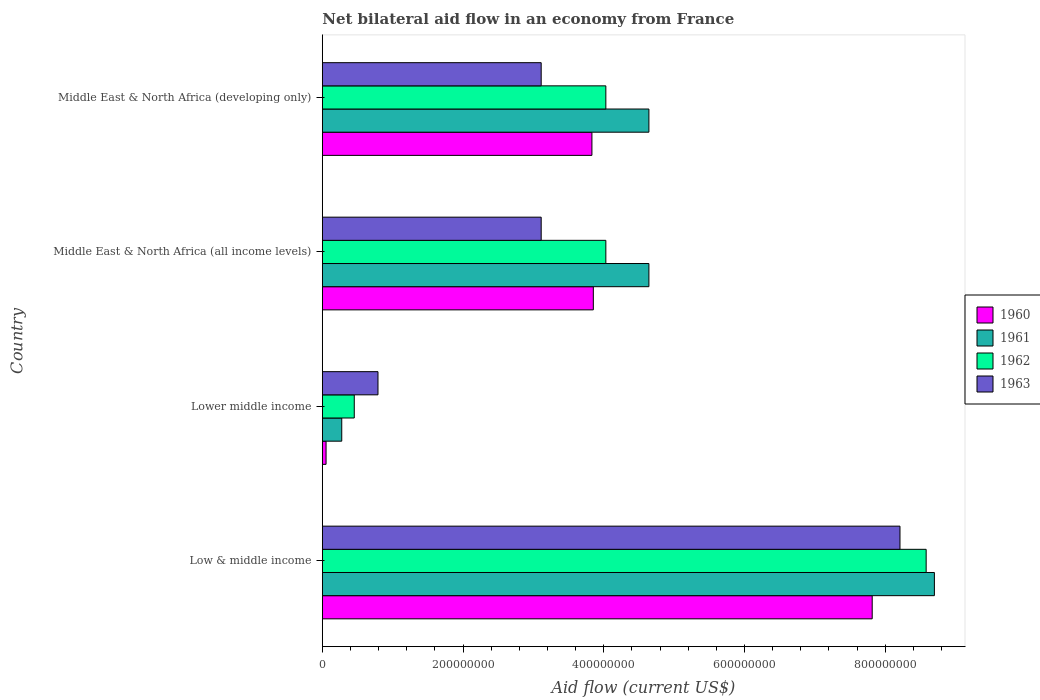How many groups of bars are there?
Offer a very short reply. 4. Are the number of bars per tick equal to the number of legend labels?
Provide a short and direct response. Yes. Are the number of bars on each tick of the Y-axis equal?
Your answer should be very brief. Yes. How many bars are there on the 3rd tick from the top?
Your response must be concise. 4. What is the label of the 4th group of bars from the top?
Your response must be concise. Low & middle income. What is the net bilateral aid flow in 1961 in Lower middle income?
Your response must be concise. 2.76e+07. Across all countries, what is the maximum net bilateral aid flow in 1962?
Make the answer very short. 8.58e+08. Across all countries, what is the minimum net bilateral aid flow in 1963?
Ensure brevity in your answer.  7.91e+07. In which country was the net bilateral aid flow in 1963 maximum?
Provide a short and direct response. Low & middle income. In which country was the net bilateral aid flow in 1961 minimum?
Offer a terse response. Lower middle income. What is the total net bilateral aid flow in 1960 in the graph?
Offer a very short reply. 1.56e+09. What is the difference between the net bilateral aid flow in 1963 in Low & middle income and that in Middle East & North Africa (developing only)?
Keep it short and to the point. 5.10e+08. What is the difference between the net bilateral aid flow in 1960 in Middle East & North Africa (all income levels) and the net bilateral aid flow in 1962 in Low & middle income?
Your response must be concise. -4.73e+08. What is the average net bilateral aid flow in 1962 per country?
Make the answer very short. 4.27e+08. What is the difference between the net bilateral aid flow in 1961 and net bilateral aid flow in 1963 in Middle East & North Africa (developing only)?
Your response must be concise. 1.53e+08. What is the ratio of the net bilateral aid flow in 1962 in Low & middle income to that in Middle East & North Africa (developing only)?
Offer a very short reply. 2.13. What is the difference between the highest and the second highest net bilateral aid flow in 1963?
Provide a succinct answer. 5.10e+08. What is the difference between the highest and the lowest net bilateral aid flow in 1963?
Offer a terse response. 7.42e+08. In how many countries, is the net bilateral aid flow in 1962 greater than the average net bilateral aid flow in 1962 taken over all countries?
Give a very brief answer. 1. Is it the case that in every country, the sum of the net bilateral aid flow in 1962 and net bilateral aid flow in 1960 is greater than the sum of net bilateral aid flow in 1963 and net bilateral aid flow in 1961?
Provide a short and direct response. No. What does the 1st bar from the top in Lower middle income represents?
Keep it short and to the point. 1963. How many bars are there?
Offer a very short reply. 16. How many countries are there in the graph?
Offer a very short reply. 4. What is the difference between two consecutive major ticks on the X-axis?
Your answer should be compact. 2.00e+08. Are the values on the major ticks of X-axis written in scientific E-notation?
Provide a short and direct response. No. What is the title of the graph?
Your response must be concise. Net bilateral aid flow in an economy from France. Does "1984" appear as one of the legend labels in the graph?
Ensure brevity in your answer.  No. What is the label or title of the X-axis?
Your response must be concise. Aid flow (current US$). What is the label or title of the Y-axis?
Offer a terse response. Country. What is the Aid flow (current US$) of 1960 in Low & middle income?
Make the answer very short. 7.82e+08. What is the Aid flow (current US$) in 1961 in Low & middle income?
Your answer should be compact. 8.70e+08. What is the Aid flow (current US$) of 1962 in Low & middle income?
Your response must be concise. 8.58e+08. What is the Aid flow (current US$) of 1963 in Low & middle income?
Provide a short and direct response. 8.21e+08. What is the Aid flow (current US$) in 1960 in Lower middle income?
Give a very brief answer. 5.30e+06. What is the Aid flow (current US$) of 1961 in Lower middle income?
Ensure brevity in your answer.  2.76e+07. What is the Aid flow (current US$) of 1962 in Lower middle income?
Provide a succinct answer. 4.54e+07. What is the Aid flow (current US$) in 1963 in Lower middle income?
Your answer should be compact. 7.91e+07. What is the Aid flow (current US$) in 1960 in Middle East & North Africa (all income levels)?
Ensure brevity in your answer.  3.85e+08. What is the Aid flow (current US$) of 1961 in Middle East & North Africa (all income levels)?
Make the answer very short. 4.64e+08. What is the Aid flow (current US$) of 1962 in Middle East & North Africa (all income levels)?
Your response must be concise. 4.03e+08. What is the Aid flow (current US$) of 1963 in Middle East & North Africa (all income levels)?
Offer a terse response. 3.11e+08. What is the Aid flow (current US$) in 1960 in Middle East & North Africa (developing only)?
Offer a terse response. 3.83e+08. What is the Aid flow (current US$) of 1961 in Middle East & North Africa (developing only)?
Your response must be concise. 4.64e+08. What is the Aid flow (current US$) in 1962 in Middle East & North Africa (developing only)?
Provide a short and direct response. 4.03e+08. What is the Aid flow (current US$) in 1963 in Middle East & North Africa (developing only)?
Provide a succinct answer. 3.11e+08. Across all countries, what is the maximum Aid flow (current US$) of 1960?
Give a very brief answer. 7.82e+08. Across all countries, what is the maximum Aid flow (current US$) in 1961?
Offer a terse response. 8.70e+08. Across all countries, what is the maximum Aid flow (current US$) in 1962?
Your answer should be compact. 8.58e+08. Across all countries, what is the maximum Aid flow (current US$) in 1963?
Your answer should be compact. 8.21e+08. Across all countries, what is the minimum Aid flow (current US$) of 1960?
Your answer should be very brief. 5.30e+06. Across all countries, what is the minimum Aid flow (current US$) in 1961?
Your answer should be very brief. 2.76e+07. Across all countries, what is the minimum Aid flow (current US$) in 1962?
Give a very brief answer. 4.54e+07. Across all countries, what is the minimum Aid flow (current US$) of 1963?
Provide a short and direct response. 7.91e+07. What is the total Aid flow (current US$) of 1960 in the graph?
Make the answer very short. 1.56e+09. What is the total Aid flow (current US$) in 1961 in the graph?
Your response must be concise. 1.83e+09. What is the total Aid flow (current US$) of 1962 in the graph?
Ensure brevity in your answer.  1.71e+09. What is the total Aid flow (current US$) in 1963 in the graph?
Ensure brevity in your answer.  1.52e+09. What is the difference between the Aid flow (current US$) in 1960 in Low & middle income and that in Lower middle income?
Your answer should be compact. 7.76e+08. What is the difference between the Aid flow (current US$) in 1961 in Low & middle income and that in Lower middle income?
Keep it short and to the point. 8.42e+08. What is the difference between the Aid flow (current US$) of 1962 in Low & middle income and that in Lower middle income?
Make the answer very short. 8.13e+08. What is the difference between the Aid flow (current US$) of 1963 in Low & middle income and that in Lower middle income?
Ensure brevity in your answer.  7.42e+08. What is the difference between the Aid flow (current US$) in 1960 in Low & middle income and that in Middle East & North Africa (all income levels)?
Your answer should be compact. 3.96e+08. What is the difference between the Aid flow (current US$) in 1961 in Low & middle income and that in Middle East & North Africa (all income levels)?
Offer a terse response. 4.06e+08. What is the difference between the Aid flow (current US$) in 1962 in Low & middle income and that in Middle East & North Africa (all income levels)?
Give a very brief answer. 4.55e+08. What is the difference between the Aid flow (current US$) in 1963 in Low & middle income and that in Middle East & North Africa (all income levels)?
Provide a succinct answer. 5.10e+08. What is the difference between the Aid flow (current US$) in 1960 in Low & middle income and that in Middle East & North Africa (developing only)?
Ensure brevity in your answer.  3.98e+08. What is the difference between the Aid flow (current US$) of 1961 in Low & middle income and that in Middle East & North Africa (developing only)?
Offer a very short reply. 4.06e+08. What is the difference between the Aid flow (current US$) in 1962 in Low & middle income and that in Middle East & North Africa (developing only)?
Offer a terse response. 4.55e+08. What is the difference between the Aid flow (current US$) in 1963 in Low & middle income and that in Middle East & North Africa (developing only)?
Your answer should be very brief. 5.10e+08. What is the difference between the Aid flow (current US$) of 1960 in Lower middle income and that in Middle East & North Africa (all income levels)?
Your response must be concise. -3.80e+08. What is the difference between the Aid flow (current US$) in 1961 in Lower middle income and that in Middle East & North Africa (all income levels)?
Ensure brevity in your answer.  -4.37e+08. What is the difference between the Aid flow (current US$) of 1962 in Lower middle income and that in Middle East & North Africa (all income levels)?
Provide a succinct answer. -3.58e+08. What is the difference between the Aid flow (current US$) of 1963 in Lower middle income and that in Middle East & North Africa (all income levels)?
Give a very brief answer. -2.32e+08. What is the difference between the Aid flow (current US$) of 1960 in Lower middle income and that in Middle East & North Africa (developing only)?
Make the answer very short. -3.78e+08. What is the difference between the Aid flow (current US$) of 1961 in Lower middle income and that in Middle East & North Africa (developing only)?
Provide a short and direct response. -4.37e+08. What is the difference between the Aid flow (current US$) in 1962 in Lower middle income and that in Middle East & North Africa (developing only)?
Offer a very short reply. -3.58e+08. What is the difference between the Aid flow (current US$) in 1963 in Lower middle income and that in Middle East & North Africa (developing only)?
Offer a very short reply. -2.32e+08. What is the difference between the Aid flow (current US$) in 1960 in Middle East & North Africa (all income levels) and that in Middle East & North Africa (developing only)?
Make the answer very short. 2.00e+06. What is the difference between the Aid flow (current US$) in 1960 in Low & middle income and the Aid flow (current US$) in 1961 in Lower middle income?
Provide a succinct answer. 7.54e+08. What is the difference between the Aid flow (current US$) in 1960 in Low & middle income and the Aid flow (current US$) in 1962 in Lower middle income?
Offer a very short reply. 7.36e+08. What is the difference between the Aid flow (current US$) of 1960 in Low & middle income and the Aid flow (current US$) of 1963 in Lower middle income?
Give a very brief answer. 7.02e+08. What is the difference between the Aid flow (current US$) in 1961 in Low & middle income and the Aid flow (current US$) in 1962 in Lower middle income?
Provide a succinct answer. 8.25e+08. What is the difference between the Aid flow (current US$) of 1961 in Low & middle income and the Aid flow (current US$) of 1963 in Lower middle income?
Provide a succinct answer. 7.91e+08. What is the difference between the Aid flow (current US$) in 1962 in Low & middle income and the Aid flow (current US$) in 1963 in Lower middle income?
Ensure brevity in your answer.  7.79e+08. What is the difference between the Aid flow (current US$) in 1960 in Low & middle income and the Aid flow (current US$) in 1961 in Middle East & North Africa (all income levels)?
Keep it short and to the point. 3.17e+08. What is the difference between the Aid flow (current US$) of 1960 in Low & middle income and the Aid flow (current US$) of 1962 in Middle East & North Africa (all income levels)?
Keep it short and to the point. 3.79e+08. What is the difference between the Aid flow (current US$) in 1960 in Low & middle income and the Aid flow (current US$) in 1963 in Middle East & North Africa (all income levels)?
Keep it short and to the point. 4.70e+08. What is the difference between the Aid flow (current US$) of 1961 in Low & middle income and the Aid flow (current US$) of 1962 in Middle East & North Africa (all income levels)?
Your answer should be compact. 4.67e+08. What is the difference between the Aid flow (current US$) of 1961 in Low & middle income and the Aid flow (current US$) of 1963 in Middle East & North Africa (all income levels)?
Keep it short and to the point. 5.59e+08. What is the difference between the Aid flow (current US$) of 1962 in Low & middle income and the Aid flow (current US$) of 1963 in Middle East & North Africa (all income levels)?
Offer a terse response. 5.47e+08. What is the difference between the Aid flow (current US$) in 1960 in Low & middle income and the Aid flow (current US$) in 1961 in Middle East & North Africa (developing only)?
Provide a succinct answer. 3.17e+08. What is the difference between the Aid flow (current US$) of 1960 in Low & middle income and the Aid flow (current US$) of 1962 in Middle East & North Africa (developing only)?
Give a very brief answer. 3.79e+08. What is the difference between the Aid flow (current US$) of 1960 in Low & middle income and the Aid flow (current US$) of 1963 in Middle East & North Africa (developing only)?
Make the answer very short. 4.70e+08. What is the difference between the Aid flow (current US$) of 1961 in Low & middle income and the Aid flow (current US$) of 1962 in Middle East & North Africa (developing only)?
Keep it short and to the point. 4.67e+08. What is the difference between the Aid flow (current US$) in 1961 in Low & middle income and the Aid flow (current US$) in 1963 in Middle East & North Africa (developing only)?
Offer a terse response. 5.59e+08. What is the difference between the Aid flow (current US$) in 1962 in Low & middle income and the Aid flow (current US$) in 1963 in Middle East & North Africa (developing only)?
Your answer should be very brief. 5.47e+08. What is the difference between the Aid flow (current US$) of 1960 in Lower middle income and the Aid flow (current US$) of 1961 in Middle East & North Africa (all income levels)?
Provide a succinct answer. -4.59e+08. What is the difference between the Aid flow (current US$) of 1960 in Lower middle income and the Aid flow (current US$) of 1962 in Middle East & North Africa (all income levels)?
Keep it short and to the point. -3.98e+08. What is the difference between the Aid flow (current US$) of 1960 in Lower middle income and the Aid flow (current US$) of 1963 in Middle East & North Africa (all income levels)?
Provide a succinct answer. -3.06e+08. What is the difference between the Aid flow (current US$) of 1961 in Lower middle income and the Aid flow (current US$) of 1962 in Middle East & North Africa (all income levels)?
Your response must be concise. -3.75e+08. What is the difference between the Aid flow (current US$) in 1961 in Lower middle income and the Aid flow (current US$) in 1963 in Middle East & North Africa (all income levels)?
Provide a short and direct response. -2.84e+08. What is the difference between the Aid flow (current US$) of 1962 in Lower middle income and the Aid flow (current US$) of 1963 in Middle East & North Africa (all income levels)?
Your answer should be very brief. -2.66e+08. What is the difference between the Aid flow (current US$) in 1960 in Lower middle income and the Aid flow (current US$) in 1961 in Middle East & North Africa (developing only)?
Provide a short and direct response. -4.59e+08. What is the difference between the Aid flow (current US$) of 1960 in Lower middle income and the Aid flow (current US$) of 1962 in Middle East & North Africa (developing only)?
Ensure brevity in your answer.  -3.98e+08. What is the difference between the Aid flow (current US$) of 1960 in Lower middle income and the Aid flow (current US$) of 1963 in Middle East & North Africa (developing only)?
Offer a terse response. -3.06e+08. What is the difference between the Aid flow (current US$) in 1961 in Lower middle income and the Aid flow (current US$) in 1962 in Middle East & North Africa (developing only)?
Your response must be concise. -3.75e+08. What is the difference between the Aid flow (current US$) in 1961 in Lower middle income and the Aid flow (current US$) in 1963 in Middle East & North Africa (developing only)?
Provide a short and direct response. -2.84e+08. What is the difference between the Aid flow (current US$) in 1962 in Lower middle income and the Aid flow (current US$) in 1963 in Middle East & North Africa (developing only)?
Keep it short and to the point. -2.66e+08. What is the difference between the Aid flow (current US$) in 1960 in Middle East & North Africa (all income levels) and the Aid flow (current US$) in 1961 in Middle East & North Africa (developing only)?
Offer a terse response. -7.90e+07. What is the difference between the Aid flow (current US$) of 1960 in Middle East & North Africa (all income levels) and the Aid flow (current US$) of 1962 in Middle East & North Africa (developing only)?
Your answer should be compact. -1.78e+07. What is the difference between the Aid flow (current US$) in 1960 in Middle East & North Africa (all income levels) and the Aid flow (current US$) in 1963 in Middle East & North Africa (developing only)?
Offer a terse response. 7.41e+07. What is the difference between the Aid flow (current US$) in 1961 in Middle East & North Africa (all income levels) and the Aid flow (current US$) in 1962 in Middle East & North Africa (developing only)?
Your response must be concise. 6.12e+07. What is the difference between the Aid flow (current US$) in 1961 in Middle East & North Africa (all income levels) and the Aid flow (current US$) in 1963 in Middle East & North Africa (developing only)?
Provide a short and direct response. 1.53e+08. What is the difference between the Aid flow (current US$) in 1962 in Middle East & North Africa (all income levels) and the Aid flow (current US$) in 1963 in Middle East & North Africa (developing only)?
Your response must be concise. 9.19e+07. What is the average Aid flow (current US$) in 1960 per country?
Keep it short and to the point. 3.89e+08. What is the average Aid flow (current US$) of 1961 per country?
Offer a terse response. 4.56e+08. What is the average Aid flow (current US$) in 1962 per country?
Your answer should be very brief. 4.27e+08. What is the average Aid flow (current US$) in 1963 per country?
Provide a succinct answer. 3.81e+08. What is the difference between the Aid flow (current US$) in 1960 and Aid flow (current US$) in 1961 in Low & middle income?
Provide a short and direct response. -8.84e+07. What is the difference between the Aid flow (current US$) in 1960 and Aid flow (current US$) in 1962 in Low & middle income?
Provide a short and direct response. -7.67e+07. What is the difference between the Aid flow (current US$) in 1960 and Aid flow (current US$) in 1963 in Low & middle income?
Your response must be concise. -3.95e+07. What is the difference between the Aid flow (current US$) in 1961 and Aid flow (current US$) in 1962 in Low & middle income?
Keep it short and to the point. 1.17e+07. What is the difference between the Aid flow (current US$) in 1961 and Aid flow (current US$) in 1963 in Low & middle income?
Your answer should be very brief. 4.89e+07. What is the difference between the Aid flow (current US$) of 1962 and Aid flow (current US$) of 1963 in Low & middle income?
Make the answer very short. 3.72e+07. What is the difference between the Aid flow (current US$) in 1960 and Aid flow (current US$) in 1961 in Lower middle income?
Keep it short and to the point. -2.23e+07. What is the difference between the Aid flow (current US$) of 1960 and Aid flow (current US$) of 1962 in Lower middle income?
Ensure brevity in your answer.  -4.01e+07. What is the difference between the Aid flow (current US$) in 1960 and Aid flow (current US$) in 1963 in Lower middle income?
Offer a terse response. -7.38e+07. What is the difference between the Aid flow (current US$) of 1961 and Aid flow (current US$) of 1962 in Lower middle income?
Provide a succinct answer. -1.78e+07. What is the difference between the Aid flow (current US$) in 1961 and Aid flow (current US$) in 1963 in Lower middle income?
Ensure brevity in your answer.  -5.15e+07. What is the difference between the Aid flow (current US$) in 1962 and Aid flow (current US$) in 1963 in Lower middle income?
Your response must be concise. -3.37e+07. What is the difference between the Aid flow (current US$) in 1960 and Aid flow (current US$) in 1961 in Middle East & North Africa (all income levels)?
Your response must be concise. -7.90e+07. What is the difference between the Aid flow (current US$) of 1960 and Aid flow (current US$) of 1962 in Middle East & North Africa (all income levels)?
Ensure brevity in your answer.  -1.78e+07. What is the difference between the Aid flow (current US$) of 1960 and Aid flow (current US$) of 1963 in Middle East & North Africa (all income levels)?
Offer a terse response. 7.41e+07. What is the difference between the Aid flow (current US$) of 1961 and Aid flow (current US$) of 1962 in Middle East & North Africa (all income levels)?
Keep it short and to the point. 6.12e+07. What is the difference between the Aid flow (current US$) of 1961 and Aid flow (current US$) of 1963 in Middle East & North Africa (all income levels)?
Your response must be concise. 1.53e+08. What is the difference between the Aid flow (current US$) of 1962 and Aid flow (current US$) of 1963 in Middle East & North Africa (all income levels)?
Offer a terse response. 9.19e+07. What is the difference between the Aid flow (current US$) in 1960 and Aid flow (current US$) in 1961 in Middle East & North Africa (developing only)?
Offer a very short reply. -8.10e+07. What is the difference between the Aid flow (current US$) in 1960 and Aid flow (current US$) in 1962 in Middle East & North Africa (developing only)?
Make the answer very short. -1.98e+07. What is the difference between the Aid flow (current US$) of 1960 and Aid flow (current US$) of 1963 in Middle East & North Africa (developing only)?
Ensure brevity in your answer.  7.21e+07. What is the difference between the Aid flow (current US$) of 1961 and Aid flow (current US$) of 1962 in Middle East & North Africa (developing only)?
Your response must be concise. 6.12e+07. What is the difference between the Aid flow (current US$) of 1961 and Aid flow (current US$) of 1963 in Middle East & North Africa (developing only)?
Ensure brevity in your answer.  1.53e+08. What is the difference between the Aid flow (current US$) in 1962 and Aid flow (current US$) in 1963 in Middle East & North Africa (developing only)?
Provide a short and direct response. 9.19e+07. What is the ratio of the Aid flow (current US$) of 1960 in Low & middle income to that in Lower middle income?
Provide a succinct answer. 147.47. What is the ratio of the Aid flow (current US$) in 1961 in Low & middle income to that in Lower middle income?
Keep it short and to the point. 31.52. What is the ratio of the Aid flow (current US$) in 1962 in Low & middle income to that in Lower middle income?
Keep it short and to the point. 18.91. What is the ratio of the Aid flow (current US$) in 1963 in Low & middle income to that in Lower middle income?
Your answer should be very brief. 10.38. What is the ratio of the Aid flow (current US$) of 1960 in Low & middle income to that in Middle East & North Africa (all income levels)?
Offer a very short reply. 2.03. What is the ratio of the Aid flow (current US$) in 1961 in Low & middle income to that in Middle East & North Africa (all income levels)?
Your answer should be very brief. 1.87. What is the ratio of the Aid flow (current US$) in 1962 in Low & middle income to that in Middle East & North Africa (all income levels)?
Your answer should be very brief. 2.13. What is the ratio of the Aid flow (current US$) in 1963 in Low & middle income to that in Middle East & North Africa (all income levels)?
Provide a succinct answer. 2.64. What is the ratio of the Aid flow (current US$) of 1960 in Low & middle income to that in Middle East & North Africa (developing only)?
Your answer should be compact. 2.04. What is the ratio of the Aid flow (current US$) in 1961 in Low & middle income to that in Middle East & North Africa (developing only)?
Your response must be concise. 1.87. What is the ratio of the Aid flow (current US$) of 1962 in Low & middle income to that in Middle East & North Africa (developing only)?
Make the answer very short. 2.13. What is the ratio of the Aid flow (current US$) of 1963 in Low & middle income to that in Middle East & North Africa (developing only)?
Your response must be concise. 2.64. What is the ratio of the Aid flow (current US$) of 1960 in Lower middle income to that in Middle East & North Africa (all income levels)?
Your answer should be compact. 0.01. What is the ratio of the Aid flow (current US$) of 1961 in Lower middle income to that in Middle East & North Africa (all income levels)?
Provide a short and direct response. 0.06. What is the ratio of the Aid flow (current US$) in 1962 in Lower middle income to that in Middle East & North Africa (all income levels)?
Ensure brevity in your answer.  0.11. What is the ratio of the Aid flow (current US$) of 1963 in Lower middle income to that in Middle East & North Africa (all income levels)?
Your answer should be compact. 0.25. What is the ratio of the Aid flow (current US$) of 1960 in Lower middle income to that in Middle East & North Africa (developing only)?
Your response must be concise. 0.01. What is the ratio of the Aid flow (current US$) in 1961 in Lower middle income to that in Middle East & North Africa (developing only)?
Your response must be concise. 0.06. What is the ratio of the Aid flow (current US$) in 1962 in Lower middle income to that in Middle East & North Africa (developing only)?
Provide a short and direct response. 0.11. What is the ratio of the Aid flow (current US$) of 1963 in Lower middle income to that in Middle East & North Africa (developing only)?
Your response must be concise. 0.25. What is the ratio of the Aid flow (current US$) of 1962 in Middle East & North Africa (all income levels) to that in Middle East & North Africa (developing only)?
Offer a very short reply. 1. What is the difference between the highest and the second highest Aid flow (current US$) of 1960?
Your response must be concise. 3.96e+08. What is the difference between the highest and the second highest Aid flow (current US$) of 1961?
Your answer should be very brief. 4.06e+08. What is the difference between the highest and the second highest Aid flow (current US$) of 1962?
Provide a succinct answer. 4.55e+08. What is the difference between the highest and the second highest Aid flow (current US$) in 1963?
Make the answer very short. 5.10e+08. What is the difference between the highest and the lowest Aid flow (current US$) of 1960?
Keep it short and to the point. 7.76e+08. What is the difference between the highest and the lowest Aid flow (current US$) in 1961?
Offer a very short reply. 8.42e+08. What is the difference between the highest and the lowest Aid flow (current US$) of 1962?
Provide a short and direct response. 8.13e+08. What is the difference between the highest and the lowest Aid flow (current US$) of 1963?
Offer a terse response. 7.42e+08. 